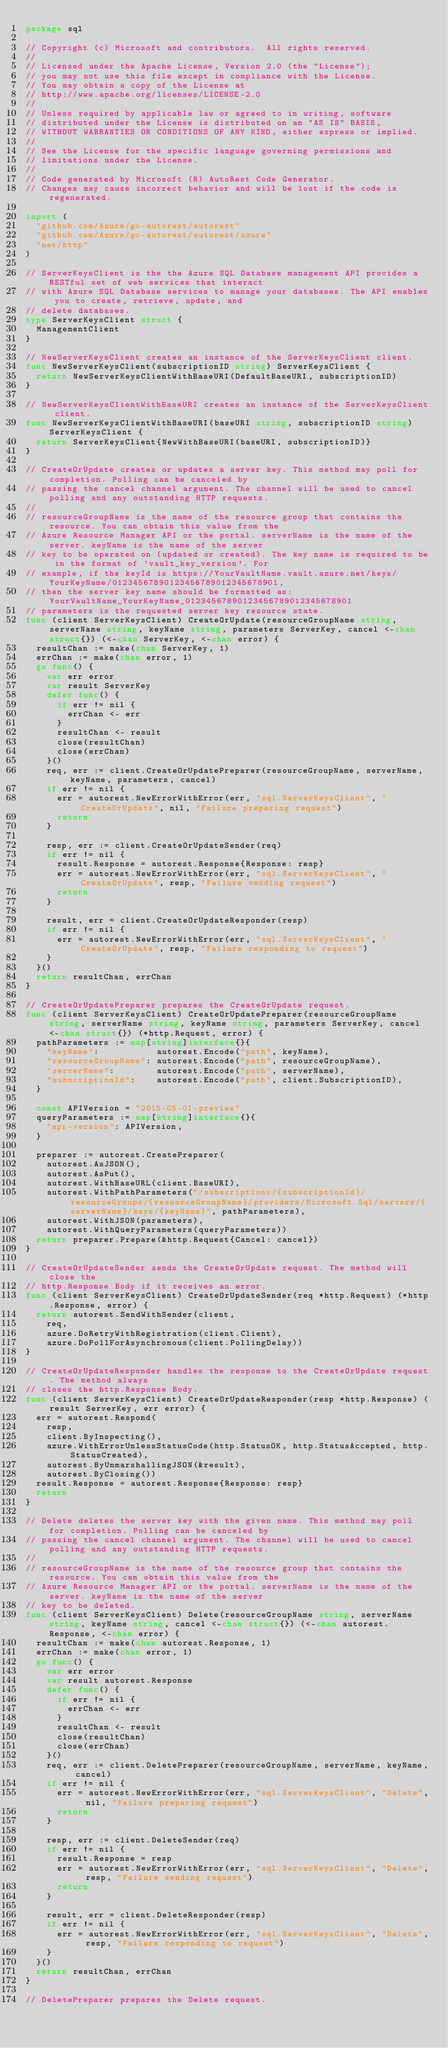Convert code to text. <code><loc_0><loc_0><loc_500><loc_500><_Go_>package sql

// Copyright (c) Microsoft and contributors.  All rights reserved.
//
// Licensed under the Apache License, Version 2.0 (the "License");
// you may not use this file except in compliance with the License.
// You may obtain a copy of the License at
// http://www.apache.org/licenses/LICENSE-2.0
//
// Unless required by applicable law or agreed to in writing, software
// distributed under the License is distributed on an "AS IS" BASIS,
// WITHOUT WARRANTIES OR CONDITIONS OF ANY KIND, either express or implied.
//
// See the License for the specific language governing permissions and
// limitations under the License.
//
// Code generated by Microsoft (R) AutoRest Code Generator.
// Changes may cause incorrect behavior and will be lost if the code is regenerated.

import (
	"github.com/Azure/go-autorest/autorest"
	"github.com/Azure/go-autorest/autorest/azure"
	"net/http"
)

// ServerKeysClient is the the Azure SQL Database management API provides a RESTful set of web services that interact
// with Azure SQL Database services to manage your databases. The API enables you to create, retrieve, update, and
// delete databases.
type ServerKeysClient struct {
	ManagementClient
}

// NewServerKeysClient creates an instance of the ServerKeysClient client.
func NewServerKeysClient(subscriptionID string) ServerKeysClient {
	return NewServerKeysClientWithBaseURI(DefaultBaseURI, subscriptionID)
}

// NewServerKeysClientWithBaseURI creates an instance of the ServerKeysClient client.
func NewServerKeysClientWithBaseURI(baseURI string, subscriptionID string) ServerKeysClient {
	return ServerKeysClient{NewWithBaseURI(baseURI, subscriptionID)}
}

// CreateOrUpdate creates or updates a server key. This method may poll for completion. Polling can be canceled by
// passing the cancel channel argument. The channel will be used to cancel polling and any outstanding HTTP requests.
//
// resourceGroupName is the name of the resource group that contains the resource. You can obtain this value from the
// Azure Resource Manager API or the portal. serverName is the name of the server. keyName is the name of the server
// key to be operated on (updated or created). The key name is required to be in the format of 'vault_key_version'. For
// example, if the keyId is https://YourVaultName.vault.azure.net/keys/YourKeyName/01234567890123456789012345678901,
// then the server key name should be formatted as: YourVaultName_YourKeyName_01234567890123456789012345678901
// parameters is the requested server key resource state.
func (client ServerKeysClient) CreateOrUpdate(resourceGroupName string, serverName string, keyName string, parameters ServerKey, cancel <-chan struct{}) (<-chan ServerKey, <-chan error) {
	resultChan := make(chan ServerKey, 1)
	errChan := make(chan error, 1)
	go func() {
		var err error
		var result ServerKey
		defer func() {
			if err != nil {
				errChan <- err
			}
			resultChan <- result
			close(resultChan)
			close(errChan)
		}()
		req, err := client.CreateOrUpdatePreparer(resourceGroupName, serverName, keyName, parameters, cancel)
		if err != nil {
			err = autorest.NewErrorWithError(err, "sql.ServerKeysClient", "CreateOrUpdate", nil, "Failure preparing request")
			return
		}

		resp, err := client.CreateOrUpdateSender(req)
		if err != nil {
			result.Response = autorest.Response{Response: resp}
			err = autorest.NewErrorWithError(err, "sql.ServerKeysClient", "CreateOrUpdate", resp, "Failure sending request")
			return
		}

		result, err = client.CreateOrUpdateResponder(resp)
		if err != nil {
			err = autorest.NewErrorWithError(err, "sql.ServerKeysClient", "CreateOrUpdate", resp, "Failure responding to request")
		}
	}()
	return resultChan, errChan
}

// CreateOrUpdatePreparer prepares the CreateOrUpdate request.
func (client ServerKeysClient) CreateOrUpdatePreparer(resourceGroupName string, serverName string, keyName string, parameters ServerKey, cancel <-chan struct{}) (*http.Request, error) {
	pathParameters := map[string]interface{}{
		"keyName":           autorest.Encode("path", keyName),
		"resourceGroupName": autorest.Encode("path", resourceGroupName),
		"serverName":        autorest.Encode("path", serverName),
		"subscriptionId":    autorest.Encode("path", client.SubscriptionID),
	}

	const APIVersion = "2015-05-01-preview"
	queryParameters := map[string]interface{}{
		"api-version": APIVersion,
	}

	preparer := autorest.CreatePreparer(
		autorest.AsJSON(),
		autorest.AsPut(),
		autorest.WithBaseURL(client.BaseURI),
		autorest.WithPathParameters("/subscriptions/{subscriptionId}/resourceGroups/{resourceGroupName}/providers/Microsoft.Sql/servers/{serverName}/keys/{keyName}", pathParameters),
		autorest.WithJSON(parameters),
		autorest.WithQueryParameters(queryParameters))
	return preparer.Prepare(&http.Request{Cancel: cancel})
}

// CreateOrUpdateSender sends the CreateOrUpdate request. The method will close the
// http.Response Body if it receives an error.
func (client ServerKeysClient) CreateOrUpdateSender(req *http.Request) (*http.Response, error) {
	return autorest.SendWithSender(client,
		req,
		azure.DoRetryWithRegistration(client.Client),
		azure.DoPollForAsynchronous(client.PollingDelay))
}

// CreateOrUpdateResponder handles the response to the CreateOrUpdate request. The method always
// closes the http.Response Body.
func (client ServerKeysClient) CreateOrUpdateResponder(resp *http.Response) (result ServerKey, err error) {
	err = autorest.Respond(
		resp,
		client.ByInspecting(),
		azure.WithErrorUnlessStatusCode(http.StatusOK, http.StatusAccepted, http.StatusCreated),
		autorest.ByUnmarshallingJSON(&result),
		autorest.ByClosing())
	result.Response = autorest.Response{Response: resp}
	return
}

// Delete deletes the server key with the given name. This method may poll for completion. Polling can be canceled by
// passing the cancel channel argument. The channel will be used to cancel polling and any outstanding HTTP requests.
//
// resourceGroupName is the name of the resource group that contains the resource. You can obtain this value from the
// Azure Resource Manager API or the portal. serverName is the name of the server. keyName is the name of the server
// key to be deleted.
func (client ServerKeysClient) Delete(resourceGroupName string, serverName string, keyName string, cancel <-chan struct{}) (<-chan autorest.Response, <-chan error) {
	resultChan := make(chan autorest.Response, 1)
	errChan := make(chan error, 1)
	go func() {
		var err error
		var result autorest.Response
		defer func() {
			if err != nil {
				errChan <- err
			}
			resultChan <- result
			close(resultChan)
			close(errChan)
		}()
		req, err := client.DeletePreparer(resourceGroupName, serverName, keyName, cancel)
		if err != nil {
			err = autorest.NewErrorWithError(err, "sql.ServerKeysClient", "Delete", nil, "Failure preparing request")
			return
		}

		resp, err := client.DeleteSender(req)
		if err != nil {
			result.Response = resp
			err = autorest.NewErrorWithError(err, "sql.ServerKeysClient", "Delete", resp, "Failure sending request")
			return
		}

		result, err = client.DeleteResponder(resp)
		if err != nil {
			err = autorest.NewErrorWithError(err, "sql.ServerKeysClient", "Delete", resp, "Failure responding to request")
		}
	}()
	return resultChan, errChan
}

// DeletePreparer prepares the Delete request.</code> 